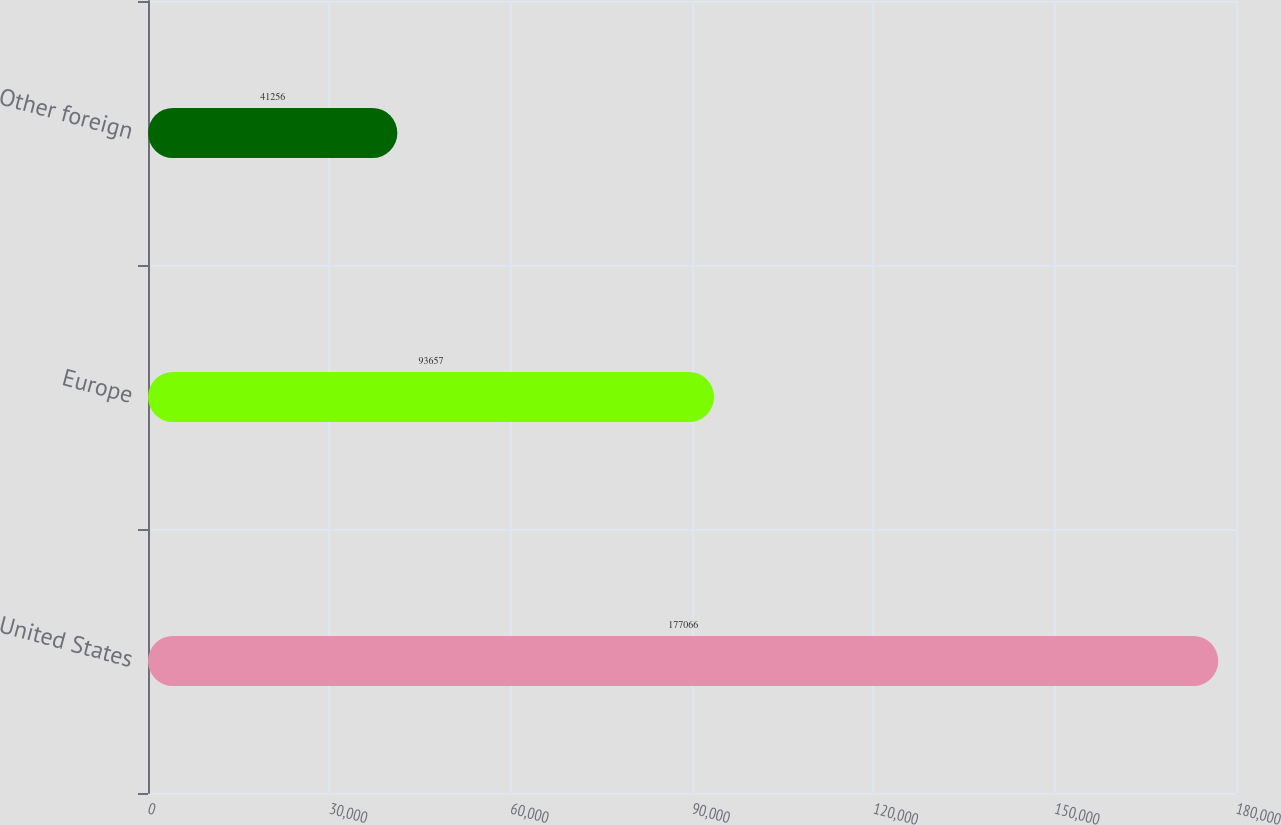Convert chart to OTSL. <chart><loc_0><loc_0><loc_500><loc_500><bar_chart><fcel>United States<fcel>Europe<fcel>Other foreign<nl><fcel>177066<fcel>93657<fcel>41256<nl></chart> 